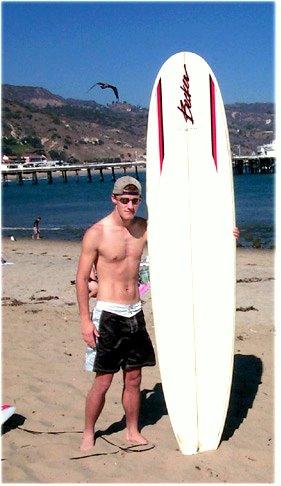Is the board white?
Keep it brief. Yes. How many birds are there?
Keep it brief. 1. What is the guy wearing?
Answer briefly. Shorts. 